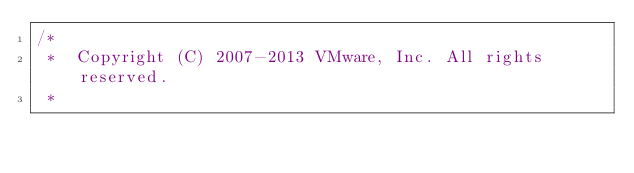Convert code to text. <code><loc_0><loc_0><loc_500><loc_500><_Java_>/*
 *  Copyright (C) 2007-2013 VMware, Inc. All rights reserved.
 *</code> 